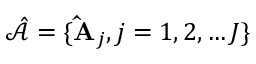<formula> <loc_0><loc_0><loc_500><loc_500>\hat { \mathcal { A } } = \{ \hat { A } _ { j } , j = 1 , 2 , \dots J \}</formula> 